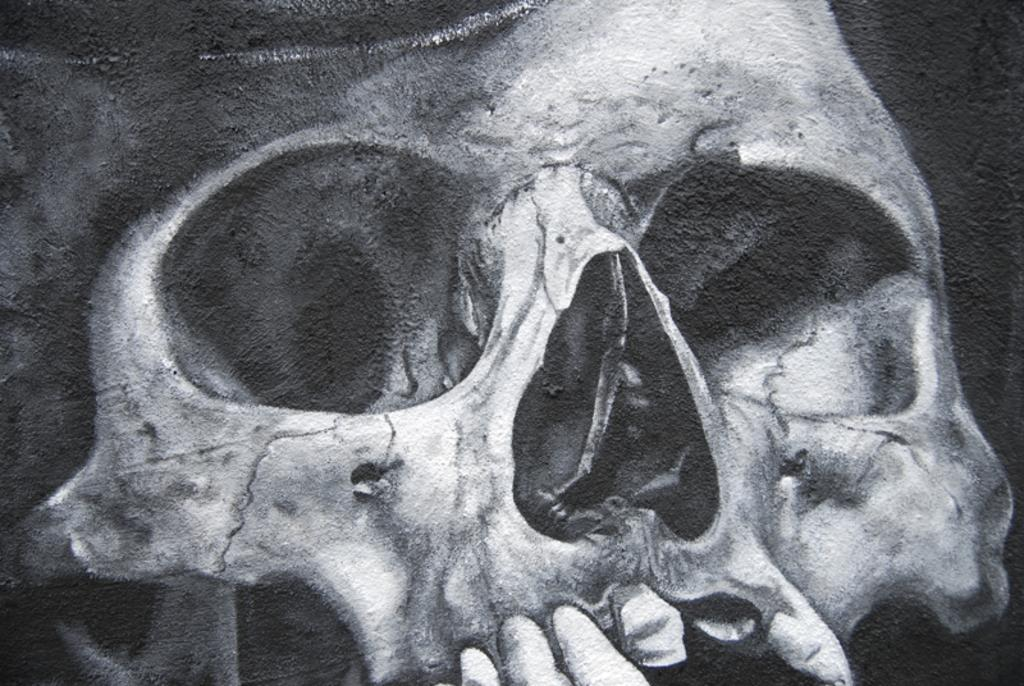What is the main subject of the image? The main subject of the image is a skull. What colors are used to depict the skull in the image? The skull is in white and black color. How many goldfish are swimming around the skull in the image? There are no goldfish present in the image; it only features a skull in white and black color. 